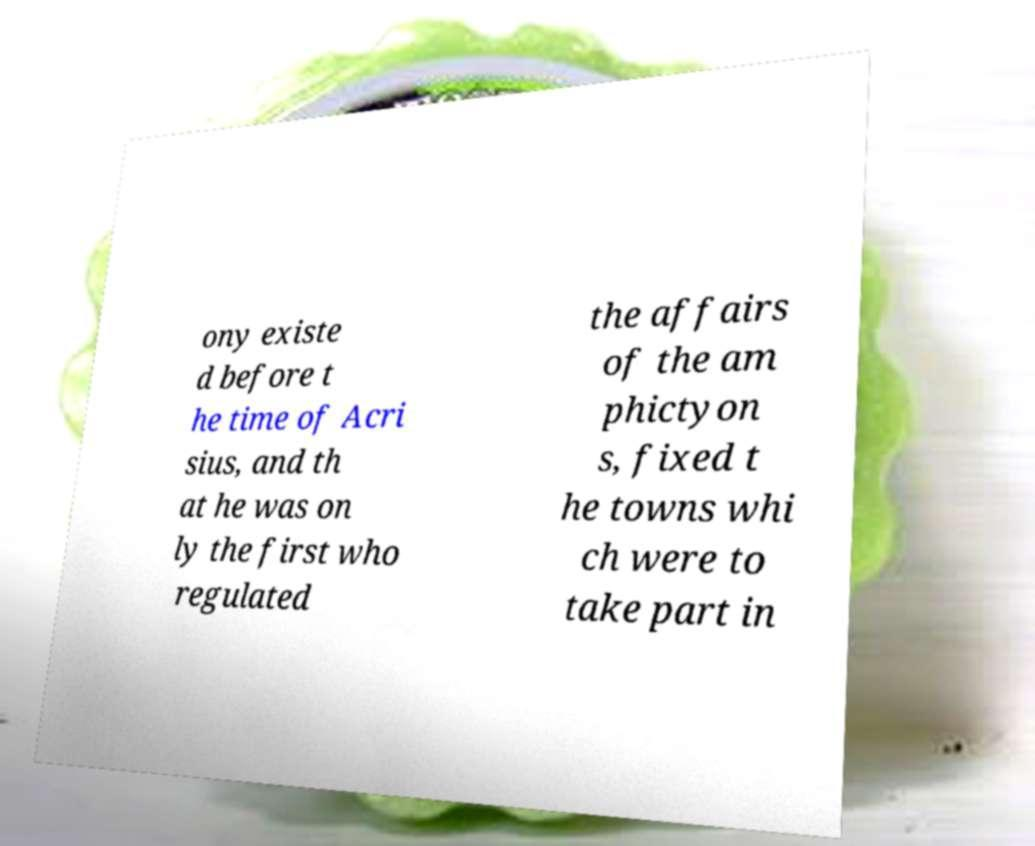For documentation purposes, I need the text within this image transcribed. Could you provide that? ony existe d before t he time of Acri sius, and th at he was on ly the first who regulated the affairs of the am phictyon s, fixed t he towns whi ch were to take part in 